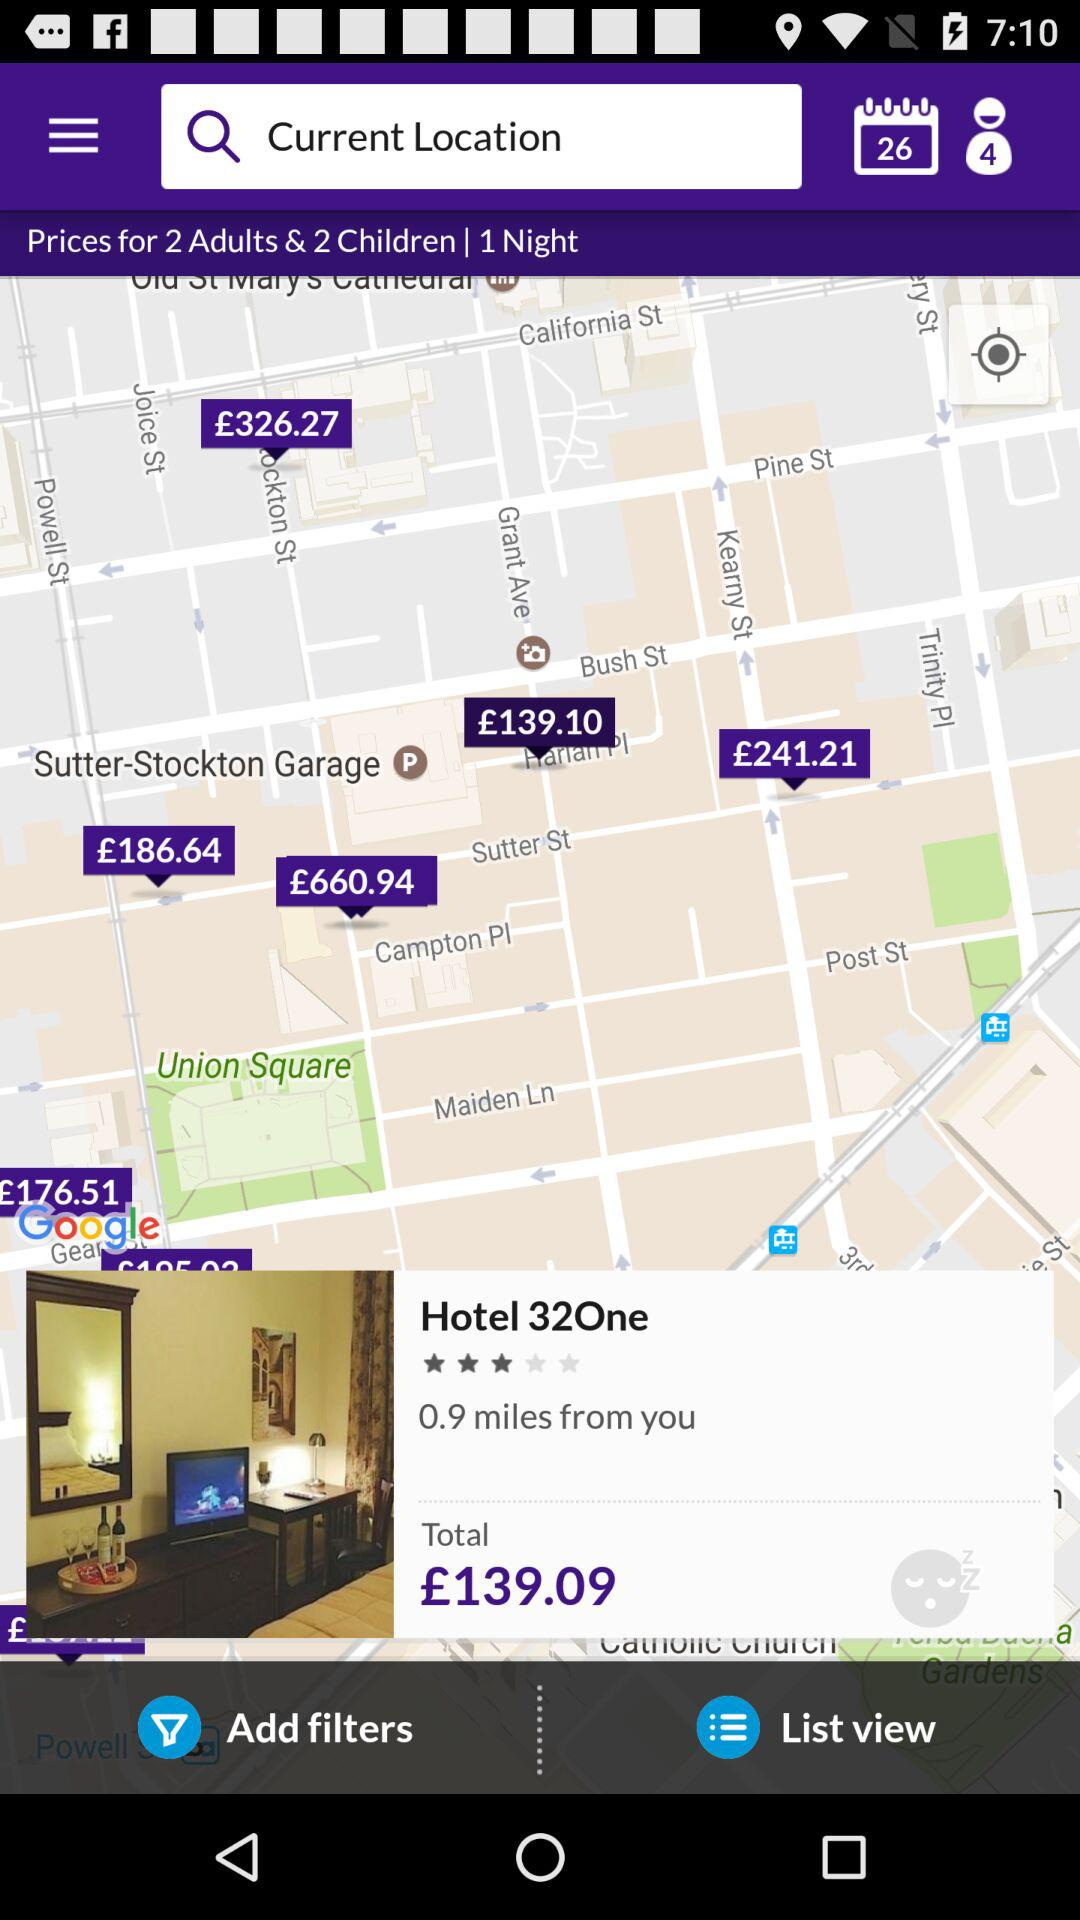How much is the total price of the hotel?
Answer the question using a single word or phrase. £139.09 